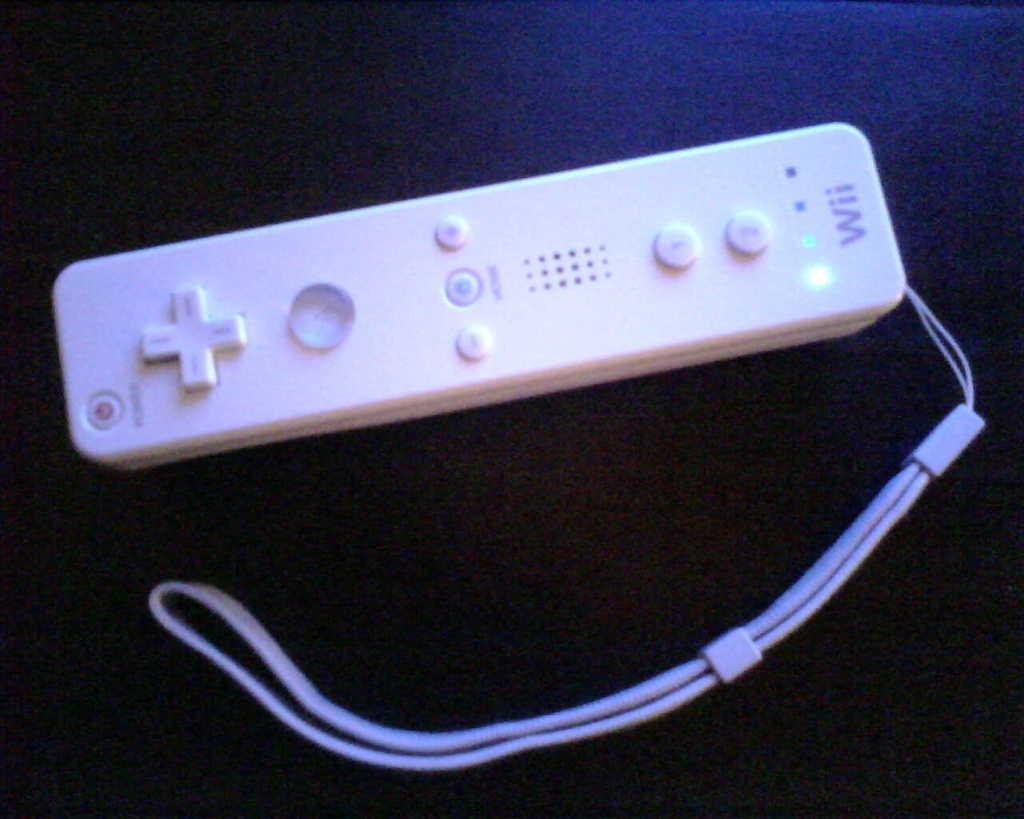Provide a one-sentence caption for the provided image. A white Wii controller is on the dark bluish purple background. 